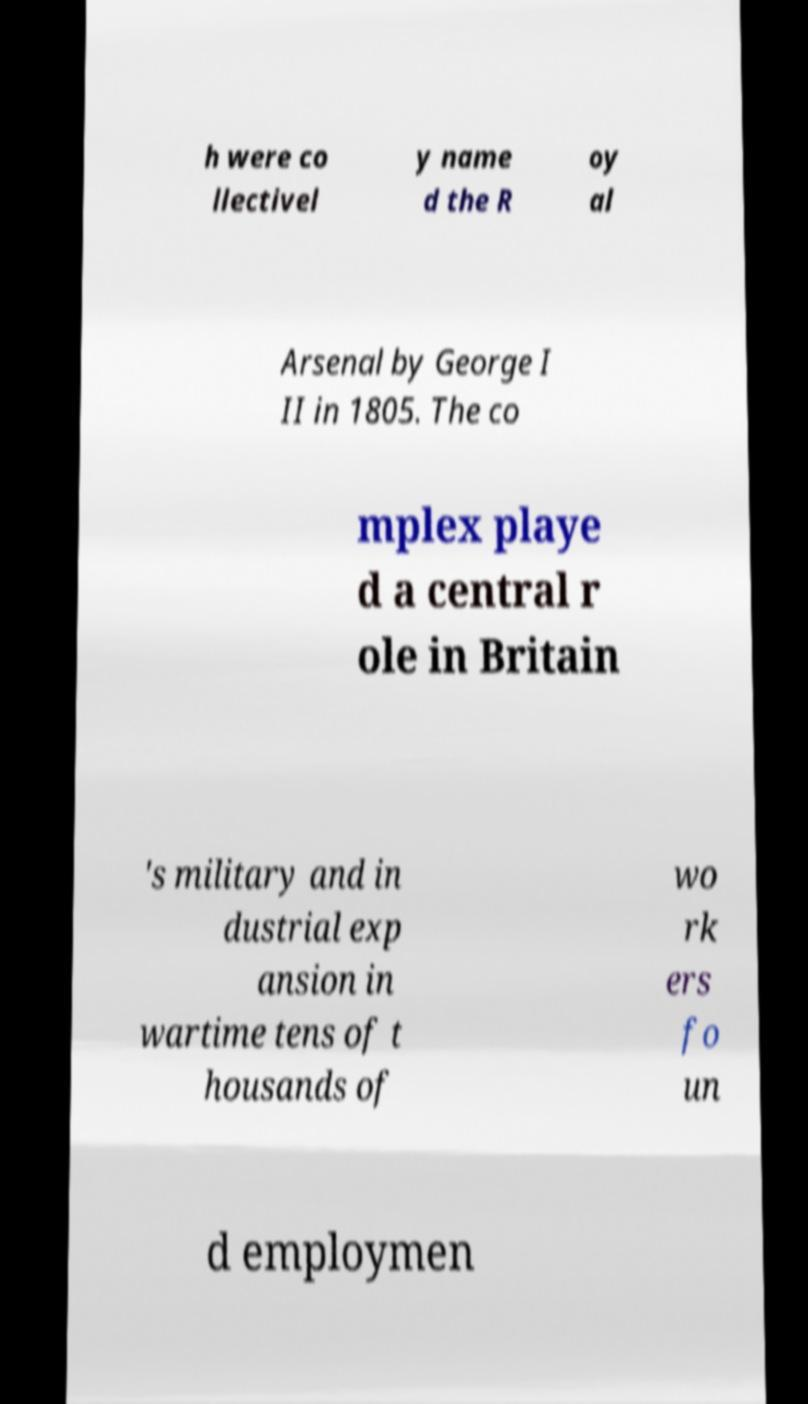Please identify and transcribe the text found in this image. h were co llectivel y name d the R oy al Arsenal by George I II in 1805. The co mplex playe d a central r ole in Britain 's military and in dustrial exp ansion in wartime tens of t housands of wo rk ers fo un d employmen 